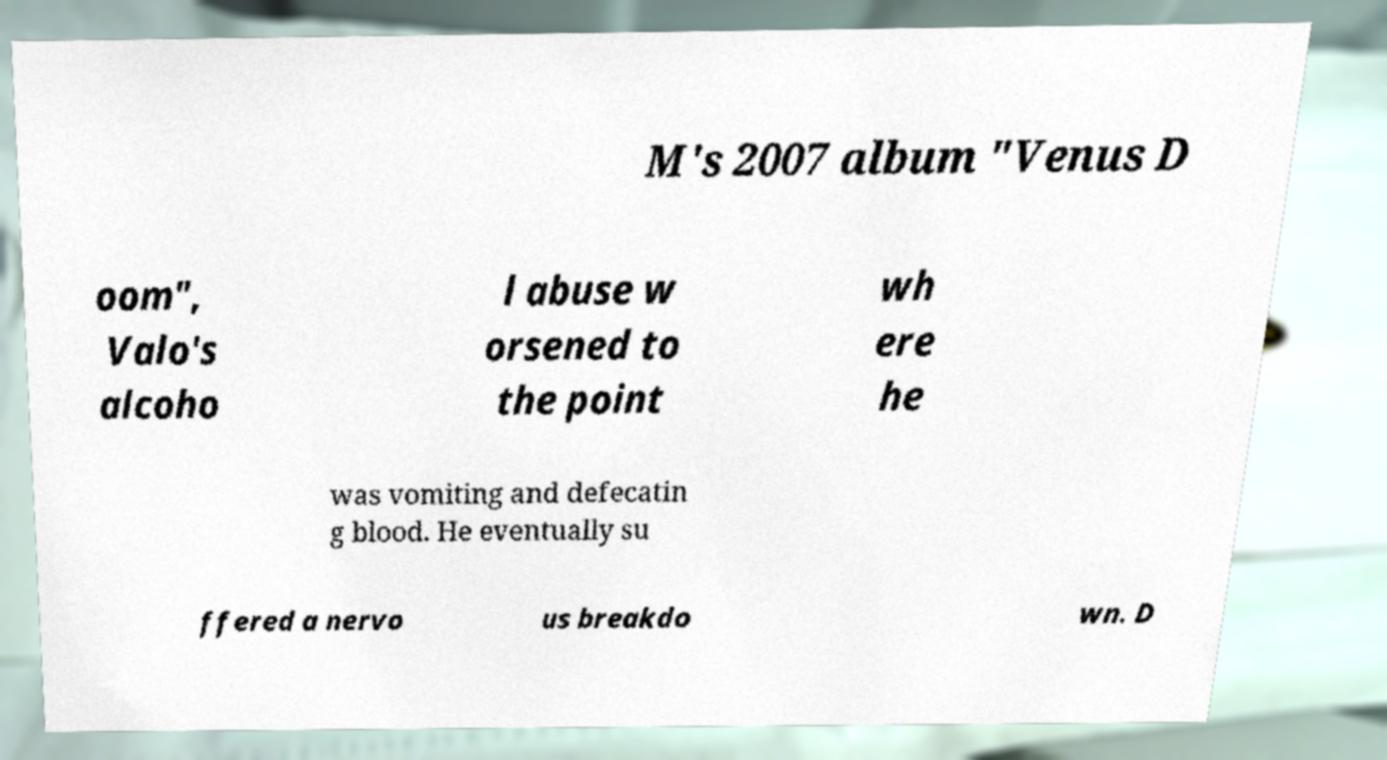Could you extract and type out the text from this image? M's 2007 album "Venus D oom", Valo's alcoho l abuse w orsened to the point wh ere he was vomiting and defecatin g blood. He eventually su ffered a nervo us breakdo wn. D 